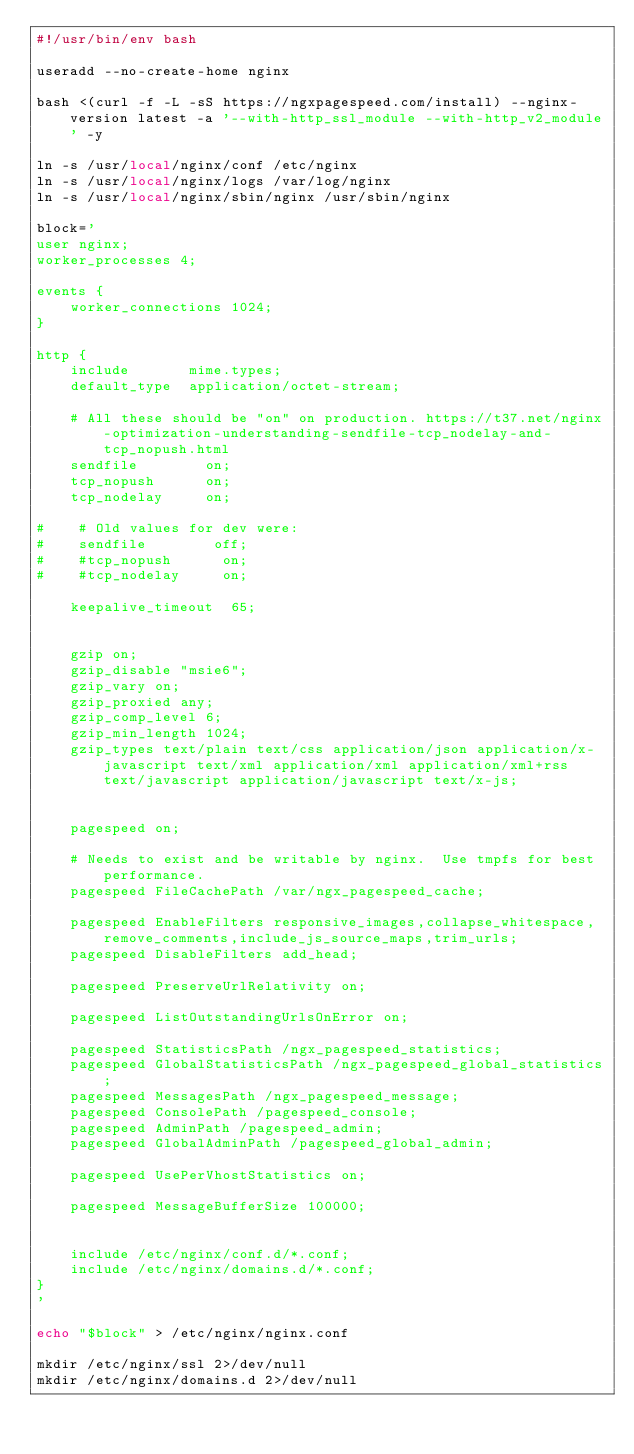Convert code to text. <code><loc_0><loc_0><loc_500><loc_500><_Bash_>#!/usr/bin/env bash

useradd --no-create-home nginx

bash <(curl -f -L -sS https://ngxpagespeed.com/install) --nginx-version latest -a '--with-http_ssl_module --with-http_v2_module' -y

ln -s /usr/local/nginx/conf /etc/nginx
ln -s /usr/local/nginx/logs /var/log/nginx
ln -s /usr/local/nginx/sbin/nginx /usr/sbin/nginx

block='
user nginx;
worker_processes 4;

events {
    worker_connections 1024;
}

http {
    include       mime.types;
    default_type  application/octet-stream;

    # All these should be "on" on production. https://t37.net/nginx-optimization-understanding-sendfile-tcp_nodelay-and-tcp_nopush.html
    sendfile        on;
    tcp_nopush      on;
    tcp_nodelay     on;

#    # Old values for dev were:
#    sendfile        off;
#    #tcp_nopush      on;
#    #tcp_nodelay     on;

    keepalive_timeout  65;


    gzip on;
    gzip_disable "msie6";
    gzip_vary on;
    gzip_proxied any;
    gzip_comp_level 6;
    gzip_min_length 1024;
    gzip_types text/plain text/css application/json application/x-javascript text/xml application/xml application/xml+rss text/javascript application/javascript text/x-js;


    pagespeed on;

    # Needs to exist and be writable by nginx.  Use tmpfs for best performance.
    pagespeed FileCachePath /var/ngx_pagespeed_cache;

    pagespeed EnableFilters responsive_images,collapse_whitespace,remove_comments,include_js_source_maps,trim_urls;
    pagespeed DisableFilters add_head;

    pagespeed PreserveUrlRelativity on;

    pagespeed ListOutstandingUrlsOnError on;

    pagespeed StatisticsPath /ngx_pagespeed_statistics;
    pagespeed GlobalStatisticsPath /ngx_pagespeed_global_statistics;
    pagespeed MessagesPath /ngx_pagespeed_message;
    pagespeed ConsolePath /pagespeed_console;
    pagespeed AdminPath /pagespeed_admin;
    pagespeed GlobalAdminPath /pagespeed_global_admin;

    pagespeed UsePerVhostStatistics on;

    pagespeed MessageBufferSize 100000;


    include /etc/nginx/conf.d/*.conf;
    include /etc/nginx/domains.d/*.conf;
}
'

echo "$block" > /etc/nginx/nginx.conf

mkdir /etc/nginx/ssl 2>/dev/null
mkdir /etc/nginx/domains.d 2>/dev/null
</code> 